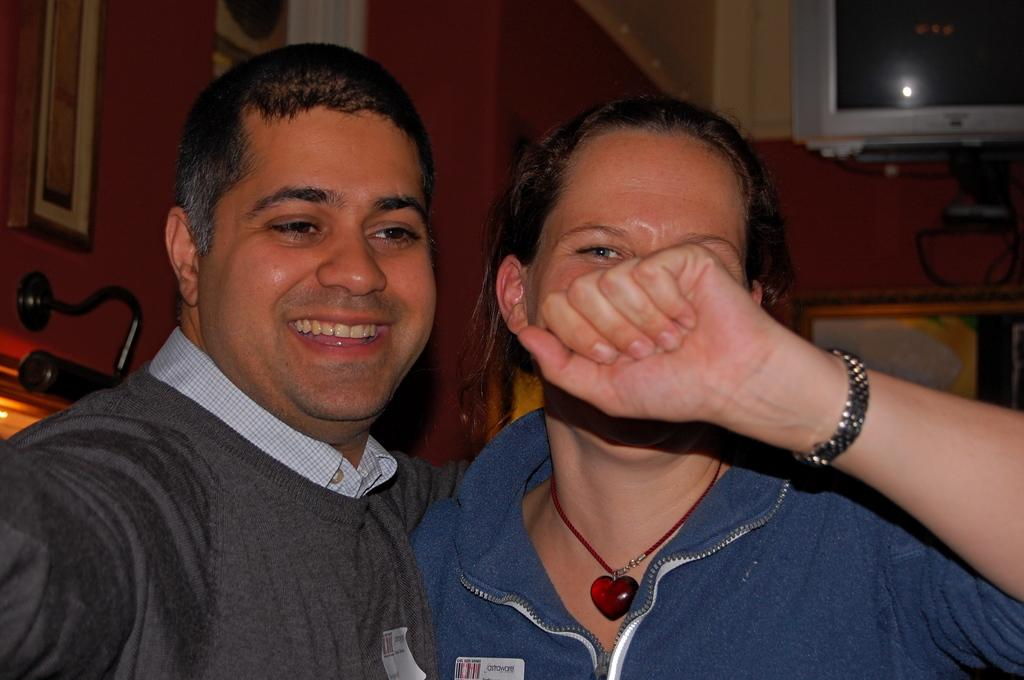How many people are in the image? There are two persons in the image. What type of setting is depicted in the image? The image appears to depict a room. Where is the light source located in the image? The light source is on the left side of the image. What type of pain is the person on the right experiencing in the image? There is no indication of pain or discomfort in the image; both persons appear to be standing or sitting normally. 